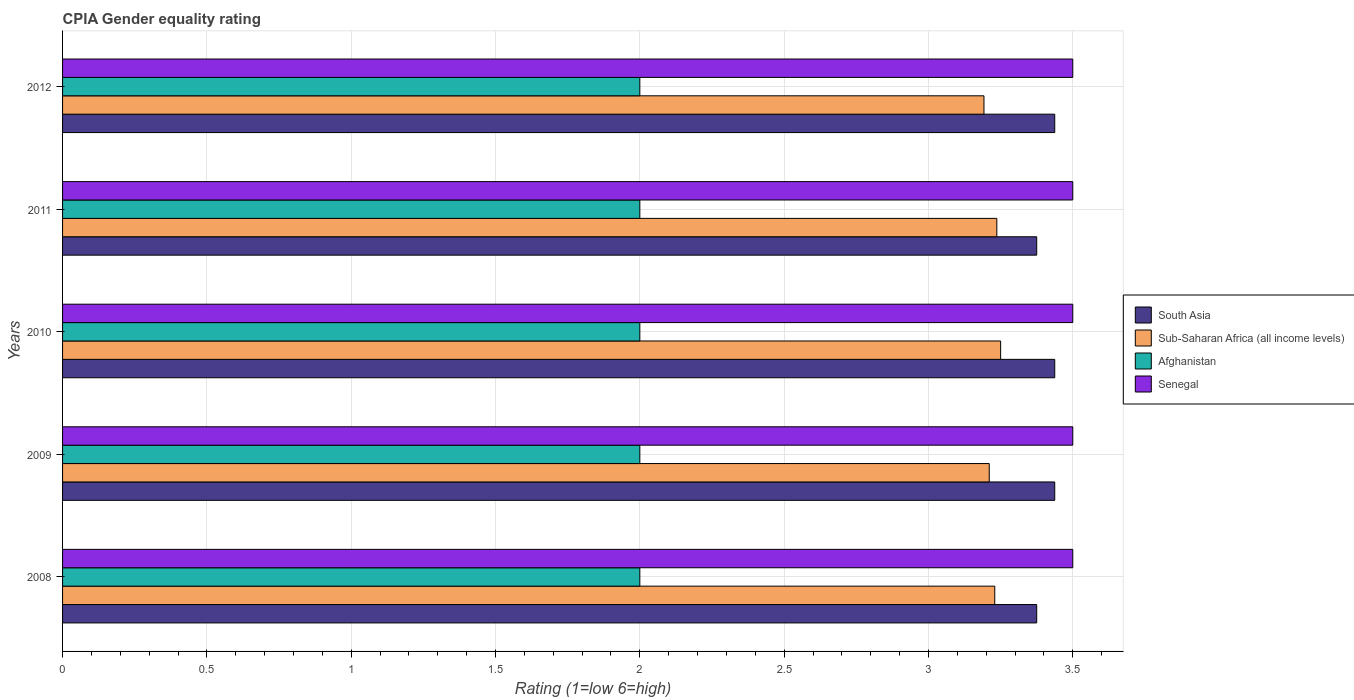How many different coloured bars are there?
Keep it short and to the point. 4. What is the label of the 4th group of bars from the top?
Keep it short and to the point. 2009. What is the CPIA rating in Senegal in 2012?
Your answer should be very brief. 3.5. What is the total CPIA rating in Senegal in the graph?
Ensure brevity in your answer.  17.5. What is the difference between the CPIA rating in Sub-Saharan Africa (all income levels) in 2010 and that in 2011?
Ensure brevity in your answer.  0.01. What is the difference between the CPIA rating in South Asia in 2009 and the CPIA rating in Sub-Saharan Africa (all income levels) in 2012?
Make the answer very short. 0.25. In the year 2009, what is the difference between the CPIA rating in Sub-Saharan Africa (all income levels) and CPIA rating in Senegal?
Make the answer very short. -0.29. In how many years, is the CPIA rating in Afghanistan greater than 1 ?
Provide a succinct answer. 5. What is the ratio of the CPIA rating in Sub-Saharan Africa (all income levels) in 2008 to that in 2012?
Keep it short and to the point. 1.01. Is the difference between the CPIA rating in Sub-Saharan Africa (all income levels) in 2009 and 2011 greater than the difference between the CPIA rating in Senegal in 2009 and 2011?
Offer a very short reply. No. What is the difference between the highest and the second highest CPIA rating in Afghanistan?
Make the answer very short. 0. What is the difference between the highest and the lowest CPIA rating in Senegal?
Ensure brevity in your answer.  0. In how many years, is the CPIA rating in Afghanistan greater than the average CPIA rating in Afghanistan taken over all years?
Your response must be concise. 0. Is the sum of the CPIA rating in Sub-Saharan Africa (all income levels) in 2009 and 2010 greater than the maximum CPIA rating in South Asia across all years?
Make the answer very short. Yes. Is it the case that in every year, the sum of the CPIA rating in Sub-Saharan Africa (all income levels) and CPIA rating in Senegal is greater than the sum of CPIA rating in Afghanistan and CPIA rating in South Asia?
Provide a succinct answer. No. What does the 4th bar from the bottom in 2012 represents?
Provide a succinct answer. Senegal. How many bars are there?
Offer a very short reply. 20. Are the values on the major ticks of X-axis written in scientific E-notation?
Make the answer very short. No. Does the graph contain any zero values?
Provide a short and direct response. No. Does the graph contain grids?
Ensure brevity in your answer.  Yes. How many legend labels are there?
Ensure brevity in your answer.  4. What is the title of the graph?
Offer a very short reply. CPIA Gender equality rating. What is the label or title of the Y-axis?
Keep it short and to the point. Years. What is the Rating (1=low 6=high) of South Asia in 2008?
Your answer should be compact. 3.38. What is the Rating (1=low 6=high) of Sub-Saharan Africa (all income levels) in 2008?
Give a very brief answer. 3.23. What is the Rating (1=low 6=high) in Afghanistan in 2008?
Make the answer very short. 2. What is the Rating (1=low 6=high) in Senegal in 2008?
Your answer should be compact. 3.5. What is the Rating (1=low 6=high) of South Asia in 2009?
Provide a short and direct response. 3.44. What is the Rating (1=low 6=high) in Sub-Saharan Africa (all income levels) in 2009?
Provide a succinct answer. 3.21. What is the Rating (1=low 6=high) in Senegal in 2009?
Ensure brevity in your answer.  3.5. What is the Rating (1=low 6=high) in South Asia in 2010?
Your answer should be compact. 3.44. What is the Rating (1=low 6=high) in Sub-Saharan Africa (all income levels) in 2010?
Keep it short and to the point. 3.25. What is the Rating (1=low 6=high) in Afghanistan in 2010?
Give a very brief answer. 2. What is the Rating (1=low 6=high) of Senegal in 2010?
Provide a short and direct response. 3.5. What is the Rating (1=low 6=high) in South Asia in 2011?
Keep it short and to the point. 3.38. What is the Rating (1=low 6=high) of Sub-Saharan Africa (all income levels) in 2011?
Offer a very short reply. 3.24. What is the Rating (1=low 6=high) in South Asia in 2012?
Make the answer very short. 3.44. What is the Rating (1=low 6=high) in Sub-Saharan Africa (all income levels) in 2012?
Ensure brevity in your answer.  3.19. What is the Rating (1=low 6=high) in Afghanistan in 2012?
Your answer should be compact. 2. What is the Rating (1=low 6=high) in Senegal in 2012?
Make the answer very short. 3.5. Across all years, what is the maximum Rating (1=low 6=high) in South Asia?
Your response must be concise. 3.44. Across all years, what is the maximum Rating (1=low 6=high) in Sub-Saharan Africa (all income levels)?
Give a very brief answer. 3.25. Across all years, what is the maximum Rating (1=low 6=high) in Senegal?
Offer a very short reply. 3.5. Across all years, what is the minimum Rating (1=low 6=high) of South Asia?
Offer a very short reply. 3.38. Across all years, what is the minimum Rating (1=low 6=high) in Sub-Saharan Africa (all income levels)?
Ensure brevity in your answer.  3.19. What is the total Rating (1=low 6=high) of South Asia in the graph?
Give a very brief answer. 17.06. What is the total Rating (1=low 6=high) in Sub-Saharan Africa (all income levels) in the graph?
Provide a short and direct response. 16.12. What is the total Rating (1=low 6=high) of Afghanistan in the graph?
Your answer should be very brief. 10. What is the difference between the Rating (1=low 6=high) of South Asia in 2008 and that in 2009?
Provide a succinct answer. -0.06. What is the difference between the Rating (1=low 6=high) of Sub-Saharan Africa (all income levels) in 2008 and that in 2009?
Make the answer very short. 0.02. What is the difference between the Rating (1=low 6=high) of Senegal in 2008 and that in 2009?
Provide a short and direct response. 0. What is the difference between the Rating (1=low 6=high) in South Asia in 2008 and that in 2010?
Provide a short and direct response. -0.06. What is the difference between the Rating (1=low 6=high) in Sub-Saharan Africa (all income levels) in 2008 and that in 2010?
Ensure brevity in your answer.  -0.02. What is the difference between the Rating (1=low 6=high) in Afghanistan in 2008 and that in 2010?
Your response must be concise. 0. What is the difference between the Rating (1=low 6=high) in Sub-Saharan Africa (all income levels) in 2008 and that in 2011?
Offer a very short reply. -0.01. What is the difference between the Rating (1=low 6=high) in South Asia in 2008 and that in 2012?
Offer a terse response. -0.06. What is the difference between the Rating (1=low 6=high) of Sub-Saharan Africa (all income levels) in 2008 and that in 2012?
Ensure brevity in your answer.  0.04. What is the difference between the Rating (1=low 6=high) in Afghanistan in 2008 and that in 2012?
Your answer should be very brief. 0. What is the difference between the Rating (1=low 6=high) in Senegal in 2008 and that in 2012?
Your response must be concise. 0. What is the difference between the Rating (1=low 6=high) of South Asia in 2009 and that in 2010?
Your answer should be very brief. 0. What is the difference between the Rating (1=low 6=high) in Sub-Saharan Africa (all income levels) in 2009 and that in 2010?
Ensure brevity in your answer.  -0.04. What is the difference between the Rating (1=low 6=high) of Senegal in 2009 and that in 2010?
Ensure brevity in your answer.  0. What is the difference between the Rating (1=low 6=high) of South Asia in 2009 and that in 2011?
Provide a succinct answer. 0.06. What is the difference between the Rating (1=low 6=high) of Sub-Saharan Africa (all income levels) in 2009 and that in 2011?
Provide a succinct answer. -0.03. What is the difference between the Rating (1=low 6=high) in South Asia in 2009 and that in 2012?
Provide a succinct answer. 0. What is the difference between the Rating (1=low 6=high) in Sub-Saharan Africa (all income levels) in 2009 and that in 2012?
Keep it short and to the point. 0.02. What is the difference between the Rating (1=low 6=high) of Afghanistan in 2009 and that in 2012?
Provide a succinct answer. 0. What is the difference between the Rating (1=low 6=high) in Senegal in 2009 and that in 2012?
Provide a succinct answer. 0. What is the difference between the Rating (1=low 6=high) of South Asia in 2010 and that in 2011?
Your answer should be very brief. 0.06. What is the difference between the Rating (1=low 6=high) of Sub-Saharan Africa (all income levels) in 2010 and that in 2011?
Provide a succinct answer. 0.01. What is the difference between the Rating (1=low 6=high) of Afghanistan in 2010 and that in 2011?
Provide a succinct answer. 0. What is the difference between the Rating (1=low 6=high) in Sub-Saharan Africa (all income levels) in 2010 and that in 2012?
Offer a very short reply. 0.06. What is the difference between the Rating (1=low 6=high) in Senegal in 2010 and that in 2012?
Provide a short and direct response. 0. What is the difference between the Rating (1=low 6=high) of South Asia in 2011 and that in 2012?
Ensure brevity in your answer.  -0.06. What is the difference between the Rating (1=low 6=high) in Sub-Saharan Africa (all income levels) in 2011 and that in 2012?
Provide a succinct answer. 0.04. What is the difference between the Rating (1=low 6=high) in South Asia in 2008 and the Rating (1=low 6=high) in Sub-Saharan Africa (all income levels) in 2009?
Offer a terse response. 0.16. What is the difference between the Rating (1=low 6=high) in South Asia in 2008 and the Rating (1=low 6=high) in Afghanistan in 2009?
Provide a short and direct response. 1.38. What is the difference between the Rating (1=low 6=high) of South Asia in 2008 and the Rating (1=low 6=high) of Senegal in 2009?
Keep it short and to the point. -0.12. What is the difference between the Rating (1=low 6=high) of Sub-Saharan Africa (all income levels) in 2008 and the Rating (1=low 6=high) of Afghanistan in 2009?
Provide a succinct answer. 1.23. What is the difference between the Rating (1=low 6=high) in Sub-Saharan Africa (all income levels) in 2008 and the Rating (1=low 6=high) in Senegal in 2009?
Make the answer very short. -0.27. What is the difference between the Rating (1=low 6=high) of Afghanistan in 2008 and the Rating (1=low 6=high) of Senegal in 2009?
Keep it short and to the point. -1.5. What is the difference between the Rating (1=low 6=high) of South Asia in 2008 and the Rating (1=low 6=high) of Afghanistan in 2010?
Provide a short and direct response. 1.38. What is the difference between the Rating (1=low 6=high) of South Asia in 2008 and the Rating (1=low 6=high) of Senegal in 2010?
Offer a terse response. -0.12. What is the difference between the Rating (1=low 6=high) of Sub-Saharan Africa (all income levels) in 2008 and the Rating (1=low 6=high) of Afghanistan in 2010?
Offer a very short reply. 1.23. What is the difference between the Rating (1=low 6=high) of Sub-Saharan Africa (all income levels) in 2008 and the Rating (1=low 6=high) of Senegal in 2010?
Give a very brief answer. -0.27. What is the difference between the Rating (1=low 6=high) in South Asia in 2008 and the Rating (1=low 6=high) in Sub-Saharan Africa (all income levels) in 2011?
Give a very brief answer. 0.14. What is the difference between the Rating (1=low 6=high) in South Asia in 2008 and the Rating (1=low 6=high) in Afghanistan in 2011?
Offer a terse response. 1.38. What is the difference between the Rating (1=low 6=high) in South Asia in 2008 and the Rating (1=low 6=high) in Senegal in 2011?
Provide a succinct answer. -0.12. What is the difference between the Rating (1=low 6=high) of Sub-Saharan Africa (all income levels) in 2008 and the Rating (1=low 6=high) of Afghanistan in 2011?
Your response must be concise. 1.23. What is the difference between the Rating (1=low 6=high) in Sub-Saharan Africa (all income levels) in 2008 and the Rating (1=low 6=high) in Senegal in 2011?
Your response must be concise. -0.27. What is the difference between the Rating (1=low 6=high) in Afghanistan in 2008 and the Rating (1=low 6=high) in Senegal in 2011?
Your answer should be compact. -1.5. What is the difference between the Rating (1=low 6=high) in South Asia in 2008 and the Rating (1=low 6=high) in Sub-Saharan Africa (all income levels) in 2012?
Offer a terse response. 0.18. What is the difference between the Rating (1=low 6=high) in South Asia in 2008 and the Rating (1=low 6=high) in Afghanistan in 2012?
Provide a succinct answer. 1.38. What is the difference between the Rating (1=low 6=high) in South Asia in 2008 and the Rating (1=low 6=high) in Senegal in 2012?
Make the answer very short. -0.12. What is the difference between the Rating (1=low 6=high) in Sub-Saharan Africa (all income levels) in 2008 and the Rating (1=low 6=high) in Afghanistan in 2012?
Provide a succinct answer. 1.23. What is the difference between the Rating (1=low 6=high) of Sub-Saharan Africa (all income levels) in 2008 and the Rating (1=low 6=high) of Senegal in 2012?
Ensure brevity in your answer.  -0.27. What is the difference between the Rating (1=low 6=high) in South Asia in 2009 and the Rating (1=low 6=high) in Sub-Saharan Africa (all income levels) in 2010?
Your response must be concise. 0.19. What is the difference between the Rating (1=low 6=high) of South Asia in 2009 and the Rating (1=low 6=high) of Afghanistan in 2010?
Your answer should be very brief. 1.44. What is the difference between the Rating (1=low 6=high) in South Asia in 2009 and the Rating (1=low 6=high) in Senegal in 2010?
Your response must be concise. -0.06. What is the difference between the Rating (1=low 6=high) in Sub-Saharan Africa (all income levels) in 2009 and the Rating (1=low 6=high) in Afghanistan in 2010?
Ensure brevity in your answer.  1.21. What is the difference between the Rating (1=low 6=high) in Sub-Saharan Africa (all income levels) in 2009 and the Rating (1=low 6=high) in Senegal in 2010?
Make the answer very short. -0.29. What is the difference between the Rating (1=low 6=high) of South Asia in 2009 and the Rating (1=low 6=high) of Sub-Saharan Africa (all income levels) in 2011?
Provide a short and direct response. 0.2. What is the difference between the Rating (1=low 6=high) of South Asia in 2009 and the Rating (1=low 6=high) of Afghanistan in 2011?
Offer a very short reply. 1.44. What is the difference between the Rating (1=low 6=high) in South Asia in 2009 and the Rating (1=low 6=high) in Senegal in 2011?
Make the answer very short. -0.06. What is the difference between the Rating (1=low 6=high) in Sub-Saharan Africa (all income levels) in 2009 and the Rating (1=low 6=high) in Afghanistan in 2011?
Make the answer very short. 1.21. What is the difference between the Rating (1=low 6=high) in Sub-Saharan Africa (all income levels) in 2009 and the Rating (1=low 6=high) in Senegal in 2011?
Make the answer very short. -0.29. What is the difference between the Rating (1=low 6=high) in Afghanistan in 2009 and the Rating (1=low 6=high) in Senegal in 2011?
Your answer should be very brief. -1.5. What is the difference between the Rating (1=low 6=high) in South Asia in 2009 and the Rating (1=low 6=high) in Sub-Saharan Africa (all income levels) in 2012?
Give a very brief answer. 0.25. What is the difference between the Rating (1=low 6=high) in South Asia in 2009 and the Rating (1=low 6=high) in Afghanistan in 2012?
Offer a terse response. 1.44. What is the difference between the Rating (1=low 6=high) in South Asia in 2009 and the Rating (1=low 6=high) in Senegal in 2012?
Make the answer very short. -0.06. What is the difference between the Rating (1=low 6=high) of Sub-Saharan Africa (all income levels) in 2009 and the Rating (1=low 6=high) of Afghanistan in 2012?
Offer a very short reply. 1.21. What is the difference between the Rating (1=low 6=high) of Sub-Saharan Africa (all income levels) in 2009 and the Rating (1=low 6=high) of Senegal in 2012?
Keep it short and to the point. -0.29. What is the difference between the Rating (1=low 6=high) in South Asia in 2010 and the Rating (1=low 6=high) in Sub-Saharan Africa (all income levels) in 2011?
Your response must be concise. 0.2. What is the difference between the Rating (1=low 6=high) of South Asia in 2010 and the Rating (1=low 6=high) of Afghanistan in 2011?
Make the answer very short. 1.44. What is the difference between the Rating (1=low 6=high) in South Asia in 2010 and the Rating (1=low 6=high) in Senegal in 2011?
Your response must be concise. -0.06. What is the difference between the Rating (1=low 6=high) in Sub-Saharan Africa (all income levels) in 2010 and the Rating (1=low 6=high) in Afghanistan in 2011?
Offer a very short reply. 1.25. What is the difference between the Rating (1=low 6=high) in South Asia in 2010 and the Rating (1=low 6=high) in Sub-Saharan Africa (all income levels) in 2012?
Provide a short and direct response. 0.25. What is the difference between the Rating (1=low 6=high) of South Asia in 2010 and the Rating (1=low 6=high) of Afghanistan in 2012?
Make the answer very short. 1.44. What is the difference between the Rating (1=low 6=high) of South Asia in 2010 and the Rating (1=low 6=high) of Senegal in 2012?
Ensure brevity in your answer.  -0.06. What is the difference between the Rating (1=low 6=high) in Sub-Saharan Africa (all income levels) in 2010 and the Rating (1=low 6=high) in Senegal in 2012?
Offer a terse response. -0.25. What is the difference between the Rating (1=low 6=high) of South Asia in 2011 and the Rating (1=low 6=high) of Sub-Saharan Africa (all income levels) in 2012?
Provide a succinct answer. 0.18. What is the difference between the Rating (1=low 6=high) in South Asia in 2011 and the Rating (1=low 6=high) in Afghanistan in 2012?
Your answer should be compact. 1.38. What is the difference between the Rating (1=low 6=high) of South Asia in 2011 and the Rating (1=low 6=high) of Senegal in 2012?
Provide a succinct answer. -0.12. What is the difference between the Rating (1=low 6=high) of Sub-Saharan Africa (all income levels) in 2011 and the Rating (1=low 6=high) of Afghanistan in 2012?
Your answer should be very brief. 1.24. What is the difference between the Rating (1=low 6=high) of Sub-Saharan Africa (all income levels) in 2011 and the Rating (1=low 6=high) of Senegal in 2012?
Give a very brief answer. -0.26. What is the average Rating (1=low 6=high) of South Asia per year?
Your answer should be very brief. 3.41. What is the average Rating (1=low 6=high) of Sub-Saharan Africa (all income levels) per year?
Make the answer very short. 3.22. What is the average Rating (1=low 6=high) in Afghanistan per year?
Keep it short and to the point. 2. In the year 2008, what is the difference between the Rating (1=low 6=high) in South Asia and Rating (1=low 6=high) in Sub-Saharan Africa (all income levels)?
Your answer should be very brief. 0.15. In the year 2008, what is the difference between the Rating (1=low 6=high) in South Asia and Rating (1=low 6=high) in Afghanistan?
Provide a short and direct response. 1.38. In the year 2008, what is the difference between the Rating (1=low 6=high) of South Asia and Rating (1=low 6=high) of Senegal?
Offer a very short reply. -0.12. In the year 2008, what is the difference between the Rating (1=low 6=high) of Sub-Saharan Africa (all income levels) and Rating (1=low 6=high) of Afghanistan?
Ensure brevity in your answer.  1.23. In the year 2008, what is the difference between the Rating (1=low 6=high) in Sub-Saharan Africa (all income levels) and Rating (1=low 6=high) in Senegal?
Provide a short and direct response. -0.27. In the year 2008, what is the difference between the Rating (1=low 6=high) in Afghanistan and Rating (1=low 6=high) in Senegal?
Provide a succinct answer. -1.5. In the year 2009, what is the difference between the Rating (1=low 6=high) in South Asia and Rating (1=low 6=high) in Sub-Saharan Africa (all income levels)?
Your response must be concise. 0.23. In the year 2009, what is the difference between the Rating (1=low 6=high) in South Asia and Rating (1=low 6=high) in Afghanistan?
Your response must be concise. 1.44. In the year 2009, what is the difference between the Rating (1=low 6=high) of South Asia and Rating (1=low 6=high) of Senegal?
Offer a terse response. -0.06. In the year 2009, what is the difference between the Rating (1=low 6=high) of Sub-Saharan Africa (all income levels) and Rating (1=low 6=high) of Afghanistan?
Ensure brevity in your answer.  1.21. In the year 2009, what is the difference between the Rating (1=low 6=high) in Sub-Saharan Africa (all income levels) and Rating (1=low 6=high) in Senegal?
Keep it short and to the point. -0.29. In the year 2009, what is the difference between the Rating (1=low 6=high) in Afghanistan and Rating (1=low 6=high) in Senegal?
Give a very brief answer. -1.5. In the year 2010, what is the difference between the Rating (1=low 6=high) in South Asia and Rating (1=low 6=high) in Sub-Saharan Africa (all income levels)?
Make the answer very short. 0.19. In the year 2010, what is the difference between the Rating (1=low 6=high) in South Asia and Rating (1=low 6=high) in Afghanistan?
Provide a succinct answer. 1.44. In the year 2010, what is the difference between the Rating (1=low 6=high) in South Asia and Rating (1=low 6=high) in Senegal?
Your answer should be compact. -0.06. In the year 2010, what is the difference between the Rating (1=low 6=high) in Sub-Saharan Africa (all income levels) and Rating (1=low 6=high) in Afghanistan?
Your answer should be compact. 1.25. In the year 2010, what is the difference between the Rating (1=low 6=high) of Sub-Saharan Africa (all income levels) and Rating (1=low 6=high) of Senegal?
Give a very brief answer. -0.25. In the year 2010, what is the difference between the Rating (1=low 6=high) in Afghanistan and Rating (1=low 6=high) in Senegal?
Give a very brief answer. -1.5. In the year 2011, what is the difference between the Rating (1=low 6=high) in South Asia and Rating (1=low 6=high) in Sub-Saharan Africa (all income levels)?
Ensure brevity in your answer.  0.14. In the year 2011, what is the difference between the Rating (1=low 6=high) in South Asia and Rating (1=low 6=high) in Afghanistan?
Make the answer very short. 1.38. In the year 2011, what is the difference between the Rating (1=low 6=high) of South Asia and Rating (1=low 6=high) of Senegal?
Your answer should be compact. -0.12. In the year 2011, what is the difference between the Rating (1=low 6=high) of Sub-Saharan Africa (all income levels) and Rating (1=low 6=high) of Afghanistan?
Provide a short and direct response. 1.24. In the year 2011, what is the difference between the Rating (1=low 6=high) in Sub-Saharan Africa (all income levels) and Rating (1=low 6=high) in Senegal?
Offer a terse response. -0.26. In the year 2012, what is the difference between the Rating (1=low 6=high) in South Asia and Rating (1=low 6=high) in Sub-Saharan Africa (all income levels)?
Provide a succinct answer. 0.25. In the year 2012, what is the difference between the Rating (1=low 6=high) of South Asia and Rating (1=low 6=high) of Afghanistan?
Provide a succinct answer. 1.44. In the year 2012, what is the difference between the Rating (1=low 6=high) of South Asia and Rating (1=low 6=high) of Senegal?
Provide a short and direct response. -0.06. In the year 2012, what is the difference between the Rating (1=low 6=high) of Sub-Saharan Africa (all income levels) and Rating (1=low 6=high) of Afghanistan?
Ensure brevity in your answer.  1.19. In the year 2012, what is the difference between the Rating (1=low 6=high) of Sub-Saharan Africa (all income levels) and Rating (1=low 6=high) of Senegal?
Keep it short and to the point. -0.31. What is the ratio of the Rating (1=low 6=high) in South Asia in 2008 to that in 2009?
Your answer should be very brief. 0.98. What is the ratio of the Rating (1=low 6=high) of Afghanistan in 2008 to that in 2009?
Offer a terse response. 1. What is the ratio of the Rating (1=low 6=high) in Senegal in 2008 to that in 2009?
Your response must be concise. 1. What is the ratio of the Rating (1=low 6=high) in South Asia in 2008 to that in 2010?
Your answer should be very brief. 0.98. What is the ratio of the Rating (1=low 6=high) of Sub-Saharan Africa (all income levels) in 2008 to that in 2011?
Offer a very short reply. 1. What is the ratio of the Rating (1=low 6=high) in Afghanistan in 2008 to that in 2011?
Offer a terse response. 1. What is the ratio of the Rating (1=low 6=high) in South Asia in 2008 to that in 2012?
Ensure brevity in your answer.  0.98. What is the ratio of the Rating (1=low 6=high) in Sub-Saharan Africa (all income levels) in 2008 to that in 2012?
Your answer should be compact. 1.01. What is the ratio of the Rating (1=low 6=high) in South Asia in 2009 to that in 2010?
Keep it short and to the point. 1. What is the ratio of the Rating (1=low 6=high) of Sub-Saharan Africa (all income levels) in 2009 to that in 2010?
Ensure brevity in your answer.  0.99. What is the ratio of the Rating (1=low 6=high) in South Asia in 2009 to that in 2011?
Provide a succinct answer. 1.02. What is the ratio of the Rating (1=low 6=high) in Senegal in 2009 to that in 2011?
Keep it short and to the point. 1. What is the ratio of the Rating (1=low 6=high) in South Asia in 2009 to that in 2012?
Your response must be concise. 1. What is the ratio of the Rating (1=low 6=high) in Sub-Saharan Africa (all income levels) in 2009 to that in 2012?
Provide a succinct answer. 1.01. What is the ratio of the Rating (1=low 6=high) of South Asia in 2010 to that in 2011?
Provide a succinct answer. 1.02. What is the ratio of the Rating (1=low 6=high) in Sub-Saharan Africa (all income levels) in 2010 to that in 2011?
Ensure brevity in your answer.  1. What is the ratio of the Rating (1=low 6=high) of Afghanistan in 2010 to that in 2011?
Offer a terse response. 1. What is the ratio of the Rating (1=low 6=high) in South Asia in 2010 to that in 2012?
Provide a short and direct response. 1. What is the ratio of the Rating (1=low 6=high) in Sub-Saharan Africa (all income levels) in 2010 to that in 2012?
Offer a very short reply. 1.02. What is the ratio of the Rating (1=low 6=high) in Senegal in 2010 to that in 2012?
Offer a terse response. 1. What is the ratio of the Rating (1=low 6=high) in South Asia in 2011 to that in 2012?
Make the answer very short. 0.98. What is the ratio of the Rating (1=low 6=high) in Sub-Saharan Africa (all income levels) in 2011 to that in 2012?
Offer a very short reply. 1.01. What is the ratio of the Rating (1=low 6=high) in Afghanistan in 2011 to that in 2012?
Provide a succinct answer. 1. What is the ratio of the Rating (1=low 6=high) of Senegal in 2011 to that in 2012?
Your answer should be compact. 1. What is the difference between the highest and the second highest Rating (1=low 6=high) in South Asia?
Provide a succinct answer. 0. What is the difference between the highest and the second highest Rating (1=low 6=high) in Sub-Saharan Africa (all income levels)?
Your response must be concise. 0.01. What is the difference between the highest and the second highest Rating (1=low 6=high) in Afghanistan?
Offer a terse response. 0. What is the difference between the highest and the second highest Rating (1=low 6=high) in Senegal?
Ensure brevity in your answer.  0. What is the difference between the highest and the lowest Rating (1=low 6=high) of South Asia?
Give a very brief answer. 0.06. What is the difference between the highest and the lowest Rating (1=low 6=high) of Sub-Saharan Africa (all income levels)?
Your answer should be very brief. 0.06. 